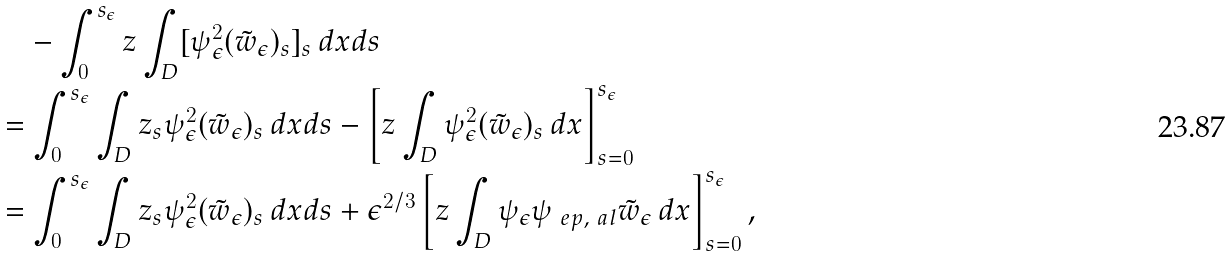Convert formula to latex. <formula><loc_0><loc_0><loc_500><loc_500>& \quad - \int _ { 0 } ^ { s _ { \epsilon } } z \int _ { D } [ \psi ^ { 2 } _ { \epsilon } ( \tilde { w } _ { \epsilon } ) _ { s } ] _ { s } \, d x d s \\ & = \int _ { 0 } ^ { s _ { \epsilon } } \int _ { D } z _ { s } \psi ^ { 2 } _ { \epsilon } ( \tilde { w } _ { \epsilon } ) _ { s } \, d x d s - \left [ z \int _ { D } \psi ^ { 2 } _ { \epsilon } ( \tilde { w } _ { \epsilon } ) _ { s } \, d x \right ] _ { s = 0 } ^ { s _ { \epsilon } } \\ & = \int _ { 0 } ^ { s _ { \epsilon } } \int _ { D } z _ { s } \psi ^ { 2 } _ { \epsilon } ( \tilde { w } _ { \epsilon } ) _ { s } \, d x d s + \epsilon ^ { 2 / 3 } \left [ z \int _ { D } \psi _ { \epsilon } \psi _ { \ e p , \ a l } \tilde { w } _ { \epsilon } \, d x \right ] _ { s = 0 } ^ { s _ { \epsilon } } ,</formula> 